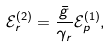<formula> <loc_0><loc_0><loc_500><loc_500>\mathcal { E } _ { r } ^ { ( 2 ) } = \frac { \bar { g } } { \gamma _ { r } } \mathcal { E } _ { p } ^ { ( 1 ) } ,</formula> 